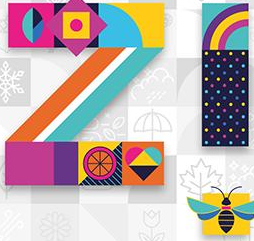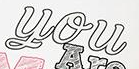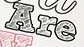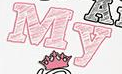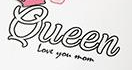Read the text from these images in sequence, separated by a semicolon. iz; You; Are; My; Queen 